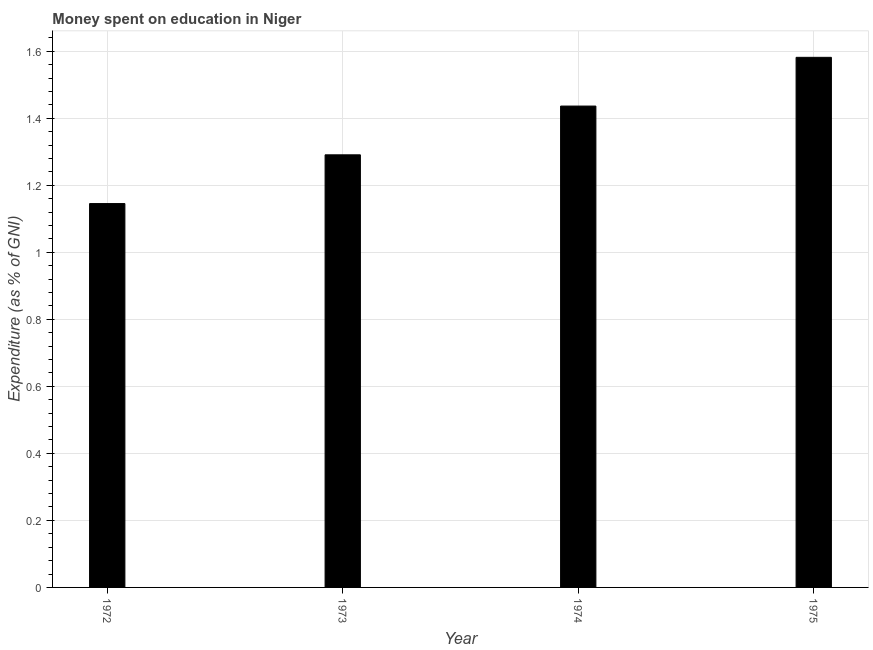Does the graph contain grids?
Your answer should be compact. Yes. What is the title of the graph?
Your answer should be compact. Money spent on education in Niger. What is the label or title of the X-axis?
Offer a very short reply. Year. What is the label or title of the Y-axis?
Ensure brevity in your answer.  Expenditure (as % of GNI). What is the expenditure on education in 1973?
Provide a short and direct response. 1.29. Across all years, what is the maximum expenditure on education?
Your response must be concise. 1.58. Across all years, what is the minimum expenditure on education?
Make the answer very short. 1.15. In which year was the expenditure on education maximum?
Your answer should be very brief. 1975. What is the sum of the expenditure on education?
Your answer should be very brief. 5.45. What is the difference between the expenditure on education in 1972 and 1973?
Give a very brief answer. -0.14. What is the average expenditure on education per year?
Keep it short and to the point. 1.36. What is the median expenditure on education?
Your answer should be very brief. 1.36. In how many years, is the expenditure on education greater than 0.56 %?
Keep it short and to the point. 4. Do a majority of the years between 1974 and 1973 (inclusive) have expenditure on education greater than 0.72 %?
Give a very brief answer. No. What is the ratio of the expenditure on education in 1974 to that in 1975?
Ensure brevity in your answer.  0.91. What is the difference between the highest and the second highest expenditure on education?
Keep it short and to the point. 0.14. Is the sum of the expenditure on education in 1972 and 1975 greater than the maximum expenditure on education across all years?
Keep it short and to the point. Yes. What is the difference between the highest and the lowest expenditure on education?
Provide a short and direct response. 0.44. How many bars are there?
Your answer should be very brief. 4. Are all the bars in the graph horizontal?
Provide a succinct answer. No. What is the Expenditure (as % of GNI) of 1972?
Provide a succinct answer. 1.15. What is the Expenditure (as % of GNI) in 1973?
Keep it short and to the point. 1.29. What is the Expenditure (as % of GNI) of 1974?
Ensure brevity in your answer.  1.44. What is the Expenditure (as % of GNI) of 1975?
Provide a short and direct response. 1.58. What is the difference between the Expenditure (as % of GNI) in 1972 and 1973?
Make the answer very short. -0.15. What is the difference between the Expenditure (as % of GNI) in 1972 and 1974?
Make the answer very short. -0.29. What is the difference between the Expenditure (as % of GNI) in 1972 and 1975?
Keep it short and to the point. -0.44. What is the difference between the Expenditure (as % of GNI) in 1973 and 1974?
Your answer should be very brief. -0.15. What is the difference between the Expenditure (as % of GNI) in 1973 and 1975?
Keep it short and to the point. -0.29. What is the difference between the Expenditure (as % of GNI) in 1974 and 1975?
Offer a terse response. -0.15. What is the ratio of the Expenditure (as % of GNI) in 1972 to that in 1973?
Ensure brevity in your answer.  0.89. What is the ratio of the Expenditure (as % of GNI) in 1972 to that in 1974?
Provide a short and direct response. 0.8. What is the ratio of the Expenditure (as % of GNI) in 1972 to that in 1975?
Provide a succinct answer. 0.72. What is the ratio of the Expenditure (as % of GNI) in 1973 to that in 1974?
Provide a succinct answer. 0.9. What is the ratio of the Expenditure (as % of GNI) in 1973 to that in 1975?
Offer a terse response. 0.82. What is the ratio of the Expenditure (as % of GNI) in 1974 to that in 1975?
Ensure brevity in your answer.  0.91. 